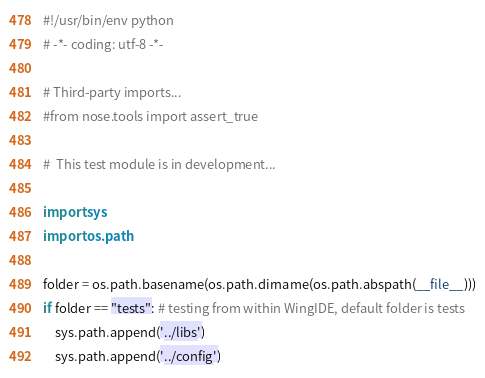<code> <loc_0><loc_0><loc_500><loc_500><_Python_>#!/usr/bin/env python
# -*- coding: utf-8 -*-

# Third-party imports...
#from nose.tools import assert_true

#  This test module is in development...

import sys
import os.path

folder = os.path.basename(os.path.dirname(os.path.abspath(__file__)))
if folder == "tests": # testing from within WingIDE, default folder is tests
    sys.path.append('../libs')
    sys.path.append('../config')</code> 